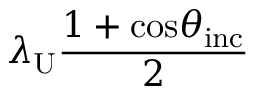Convert formula to latex. <formula><loc_0><loc_0><loc_500><loc_500>\lambda _ { U } \frac { 1 + \cos \theta _ { i n c } } { 2 }</formula> 